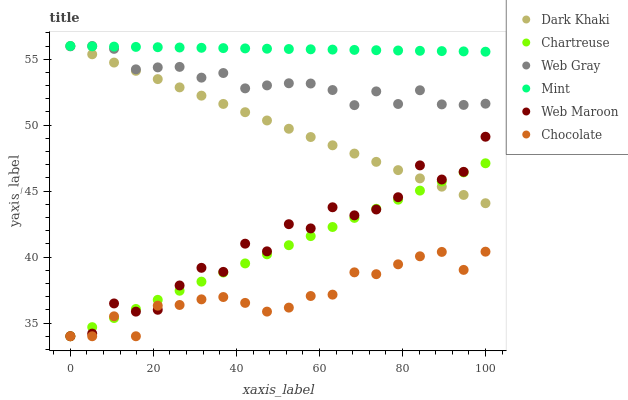Does Chocolate have the minimum area under the curve?
Answer yes or no. Yes. Does Mint have the maximum area under the curve?
Answer yes or no. Yes. Does Web Maroon have the minimum area under the curve?
Answer yes or no. No. Does Web Maroon have the maximum area under the curve?
Answer yes or no. No. Is Mint the smoothest?
Answer yes or no. Yes. Is Web Maroon the roughest?
Answer yes or no. Yes. Is Chocolate the smoothest?
Answer yes or no. No. Is Chocolate the roughest?
Answer yes or no. No. Does Web Maroon have the lowest value?
Answer yes or no. Yes. Does Dark Khaki have the lowest value?
Answer yes or no. No. Does Mint have the highest value?
Answer yes or no. Yes. Does Web Maroon have the highest value?
Answer yes or no. No. Is Chocolate less than Web Gray?
Answer yes or no. Yes. Is Web Gray greater than Web Maroon?
Answer yes or no. Yes. Does Chocolate intersect Chartreuse?
Answer yes or no. Yes. Is Chocolate less than Chartreuse?
Answer yes or no. No. Is Chocolate greater than Chartreuse?
Answer yes or no. No. Does Chocolate intersect Web Gray?
Answer yes or no. No. 